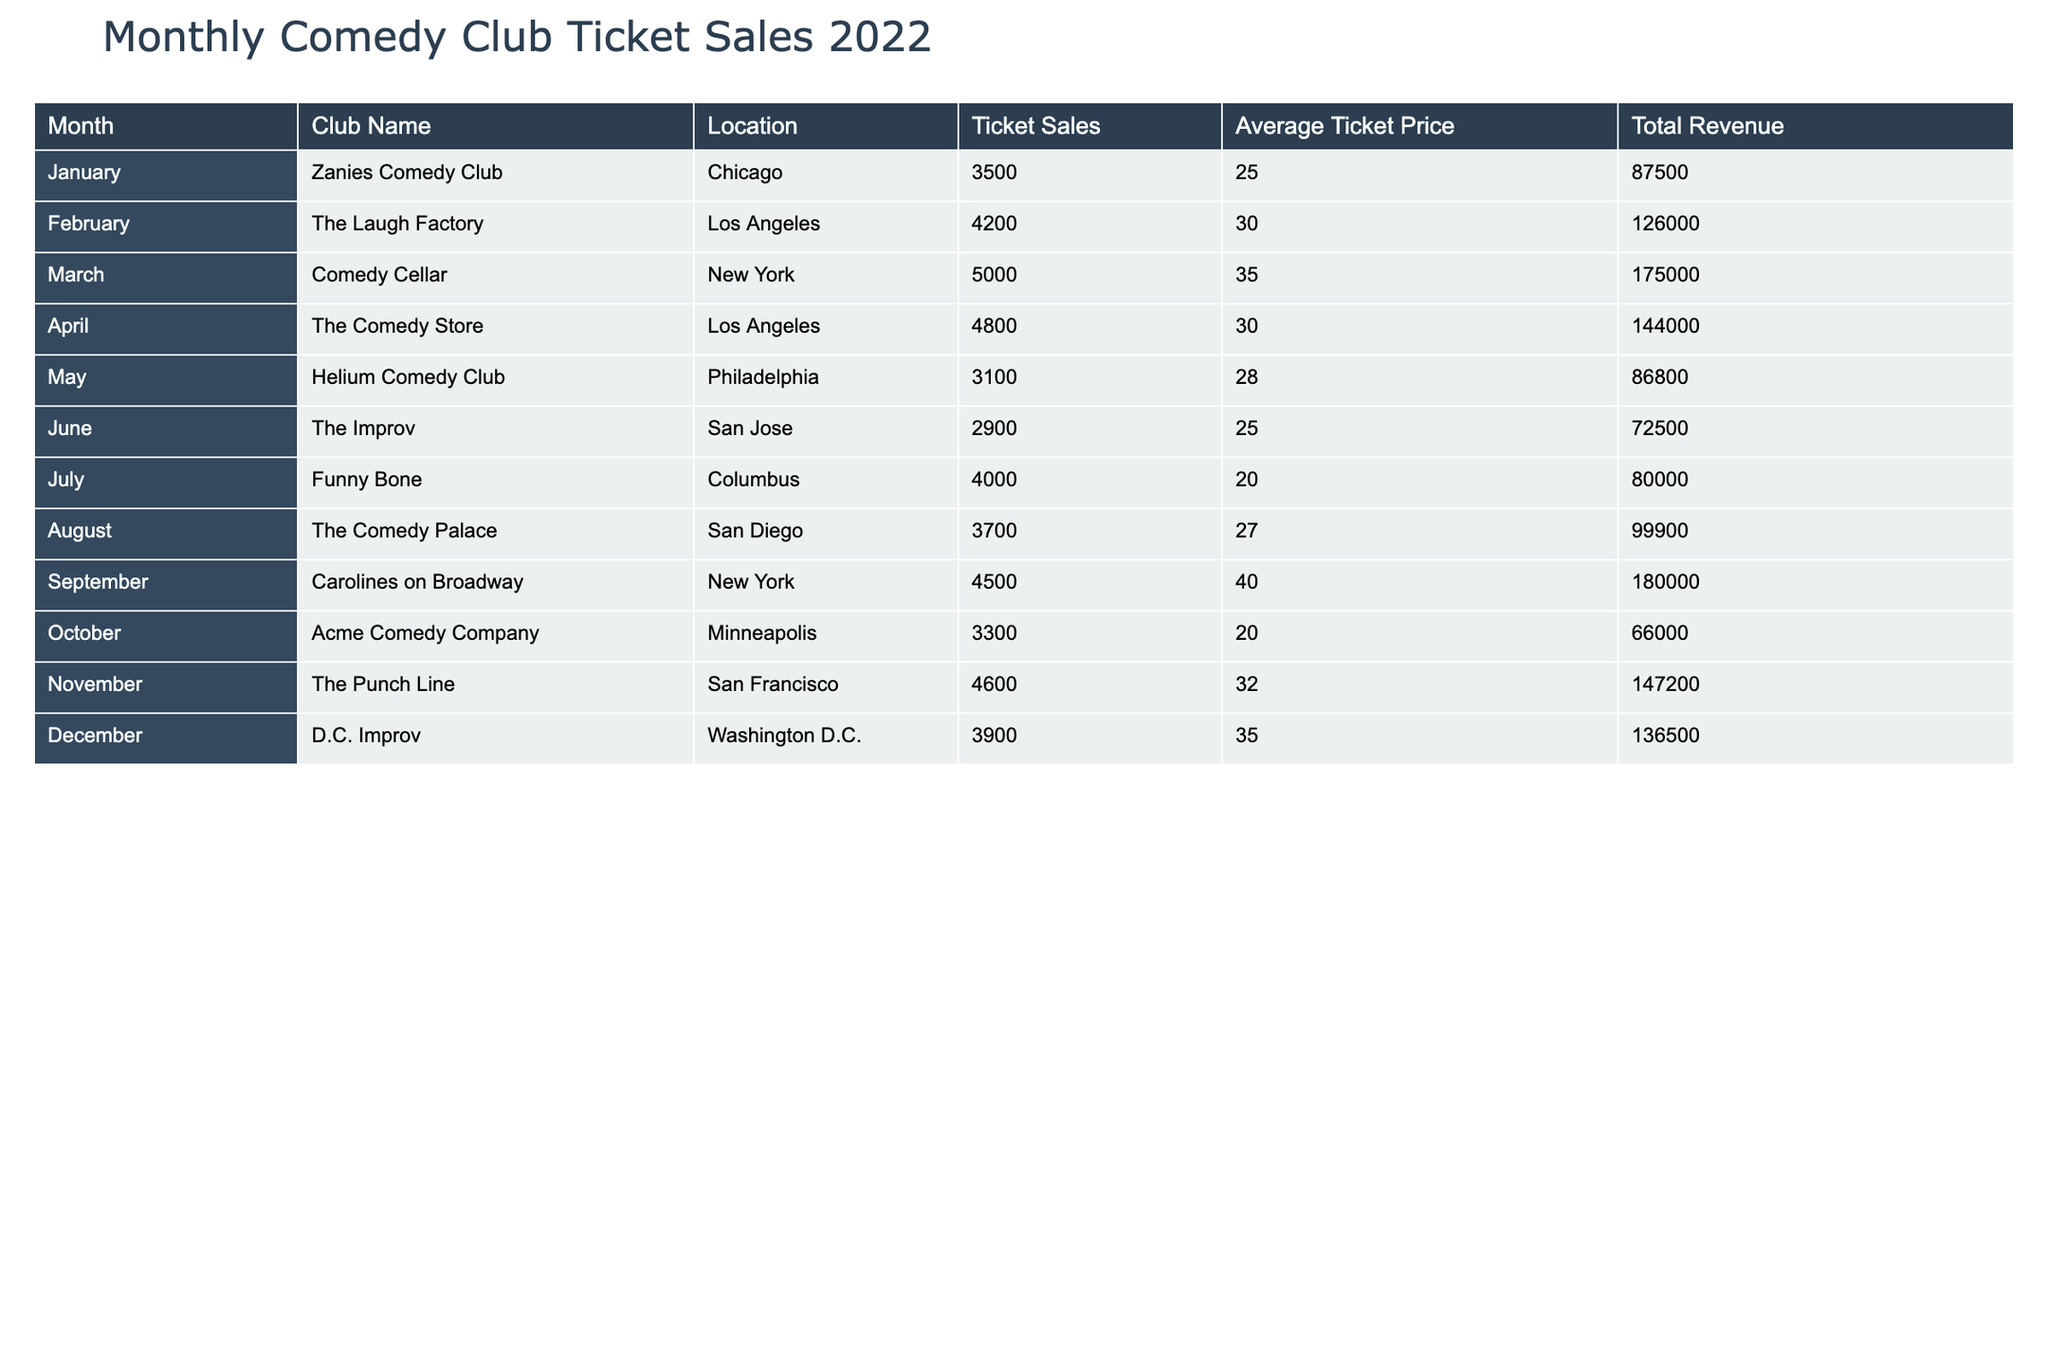What was the total ticket sales for Comedy Cellar in March? The ticket sales for Comedy Cellar in March is listed directly in the table. We can see that the value is 5000.
Answer: 5000 Which club had the highest ticket sales in January? Looking at the table for January, Zanies Comedy Club is the only club listed, and it had ticket sales of 3500.
Answer: Yes, Zanies Comedy Club What is the average ticket price for all clubs in December? To find the average ticket price for December, we refer to the ticket prices listed. The only value available is 35 from D.C. Improv. Since there is only one club for December, the average is also 35.
Answer: 35 Which two months had the highest total revenue, and what was the total revenue for those months? From the table, we find the total revenue for each month. September had 180000 revenue, and March had 175000 revenue. The sum of these two values is 180000 + 175000 = 355000.
Answer: September: 180000, March: 175000; Total: 355000 Did the Funny Bone in July sell more tickets than Helium Comedy Club in May? Comparing the ticket sales from the table, Funny Bone had 4000 ticket sales while Helium Comedy Club had 3100. Since 4000 is greater than 3100, the statement is true.
Answer: Yes What is the total revenue for all clubs in Los Angeles? The clubs listed in Los Angeles are The Laugh Factory and The Comedy Store. The revenues are 126000 and 144000 respectively. Adding these gives 126000 + 144000 = 270000.
Answer: 270000 Which month had lower ticket sales, August or October? Ticket sales for August were 3700, and for October, it was 3300. Since 3300 is less than 3700, October had lower sales.
Answer: October What is the total number of ticket sales for the clubs located in New York? There are two clubs in New York: Comedy Cellar with 5000 ticket sales and Carolines on Broadway with 4500 ticket sales. Adding these gives us 5000 + 4500 = 9500.
Answer: 9500 